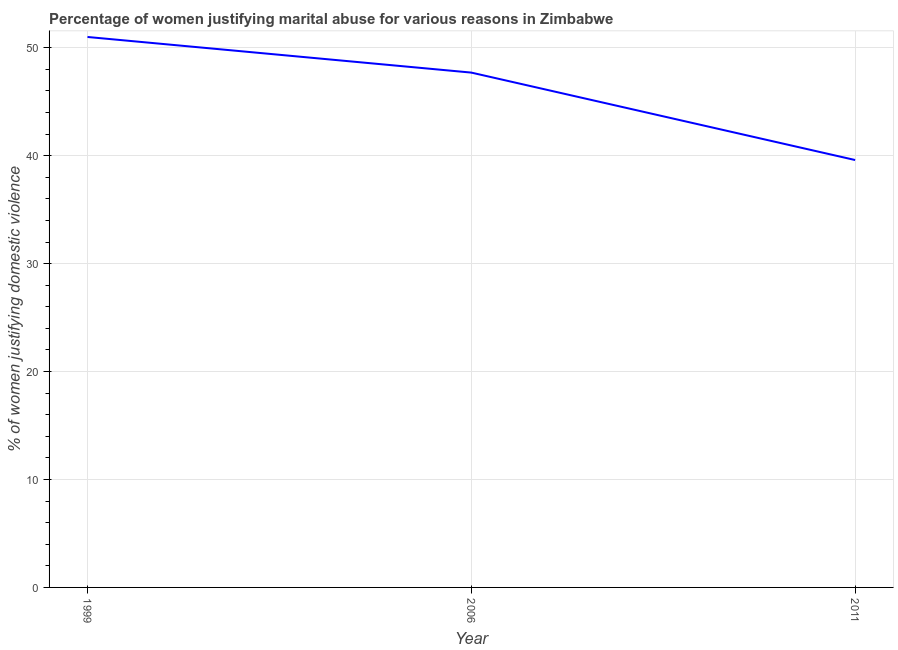Across all years, what is the maximum percentage of women justifying marital abuse?
Provide a succinct answer. 51. Across all years, what is the minimum percentage of women justifying marital abuse?
Your response must be concise. 39.6. In which year was the percentage of women justifying marital abuse maximum?
Provide a succinct answer. 1999. What is the sum of the percentage of women justifying marital abuse?
Provide a short and direct response. 138.3. What is the difference between the percentage of women justifying marital abuse in 1999 and 2006?
Ensure brevity in your answer.  3.3. What is the average percentage of women justifying marital abuse per year?
Your answer should be very brief. 46.1. What is the median percentage of women justifying marital abuse?
Your answer should be very brief. 47.7. What is the ratio of the percentage of women justifying marital abuse in 1999 to that in 2006?
Make the answer very short. 1.07. What is the difference between the highest and the second highest percentage of women justifying marital abuse?
Provide a short and direct response. 3.3. What is the difference between the highest and the lowest percentage of women justifying marital abuse?
Give a very brief answer. 11.4. Does the percentage of women justifying marital abuse monotonically increase over the years?
Offer a terse response. No. How many lines are there?
Provide a short and direct response. 1. Does the graph contain any zero values?
Give a very brief answer. No. Does the graph contain grids?
Your response must be concise. Yes. What is the title of the graph?
Offer a terse response. Percentage of women justifying marital abuse for various reasons in Zimbabwe. What is the label or title of the X-axis?
Your answer should be compact. Year. What is the label or title of the Y-axis?
Make the answer very short. % of women justifying domestic violence. What is the % of women justifying domestic violence in 2006?
Make the answer very short. 47.7. What is the % of women justifying domestic violence of 2011?
Ensure brevity in your answer.  39.6. What is the difference between the % of women justifying domestic violence in 1999 and 2011?
Offer a very short reply. 11.4. What is the ratio of the % of women justifying domestic violence in 1999 to that in 2006?
Your response must be concise. 1.07. What is the ratio of the % of women justifying domestic violence in 1999 to that in 2011?
Ensure brevity in your answer.  1.29. What is the ratio of the % of women justifying domestic violence in 2006 to that in 2011?
Your answer should be very brief. 1.21. 